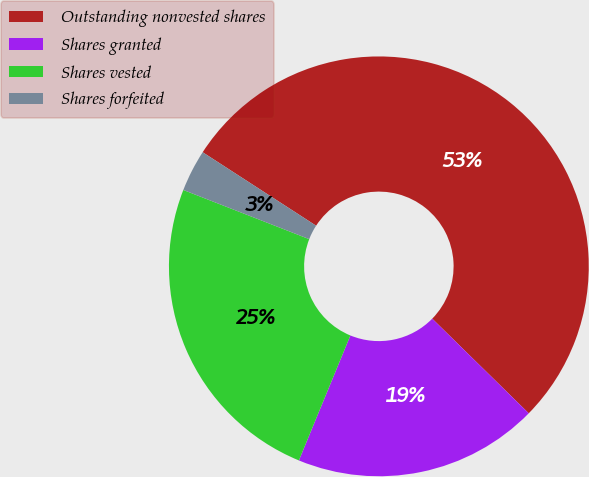Convert chart. <chart><loc_0><loc_0><loc_500><loc_500><pie_chart><fcel>Outstanding nonvested shares<fcel>Shares granted<fcel>Shares vested<fcel>Shares forfeited<nl><fcel>53.2%<fcel>18.88%<fcel>24.71%<fcel>3.22%<nl></chart> 